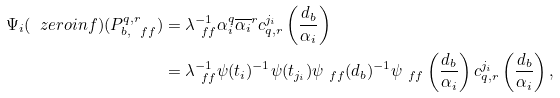<formula> <loc_0><loc_0><loc_500><loc_500>\Psi _ { i } ( \ z e r o i n f ) ( P _ { b , \ f f } ^ { q , r } ) & = \lambda _ { \ f f } ^ { - 1 } \alpha _ { i } ^ { q } \overline { \alpha _ { i } } ^ { r } c _ { q , r } ^ { j _ { i } } \left ( \frac { d _ { b } } { \alpha _ { i } } \right ) \\ & = \lambda _ { \ f f } ^ { - 1 } \psi ( t _ { i } ) ^ { - 1 } \psi ( t _ { j _ { i } } ) \psi _ { \ f f } ( d _ { b } ) ^ { - 1 } \psi _ { \ f f } \left ( \frac { d _ { b } } { \alpha _ { i } } \right ) c _ { q , r } ^ { j _ { i } } \left ( \frac { d _ { b } } { \alpha _ { i } } \right ) ,</formula> 